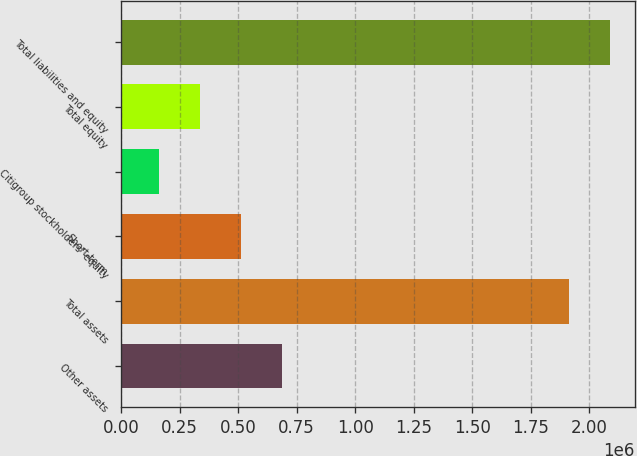Convert chart to OTSL. <chart><loc_0><loc_0><loc_500><loc_500><bar_chart><fcel>Other assets<fcel>Total assets<fcel>Short-term<fcel>Citigroup stockholders' equity<fcel>Total equity<fcel>Total liabilities and equity<nl><fcel>688598<fcel>1.9139e+06<fcel>513555<fcel>163468<fcel>338511<fcel>2.08895e+06<nl></chart> 